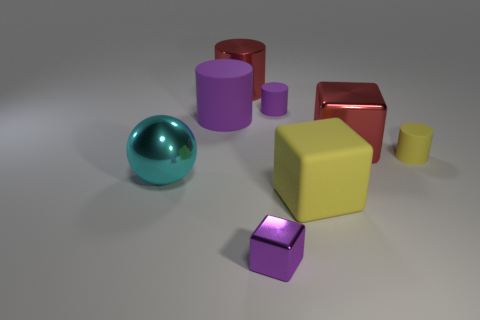Add 2 large red shiny objects. How many objects exist? 10 Subtract all balls. How many objects are left? 7 Subtract 1 cyan spheres. How many objects are left? 7 Subtract all tiny metallic objects. Subtract all big metallic objects. How many objects are left? 4 Add 8 big matte cubes. How many big matte cubes are left? 9 Add 7 purple cylinders. How many purple cylinders exist? 9 